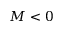<formula> <loc_0><loc_0><loc_500><loc_500>M < 0</formula> 